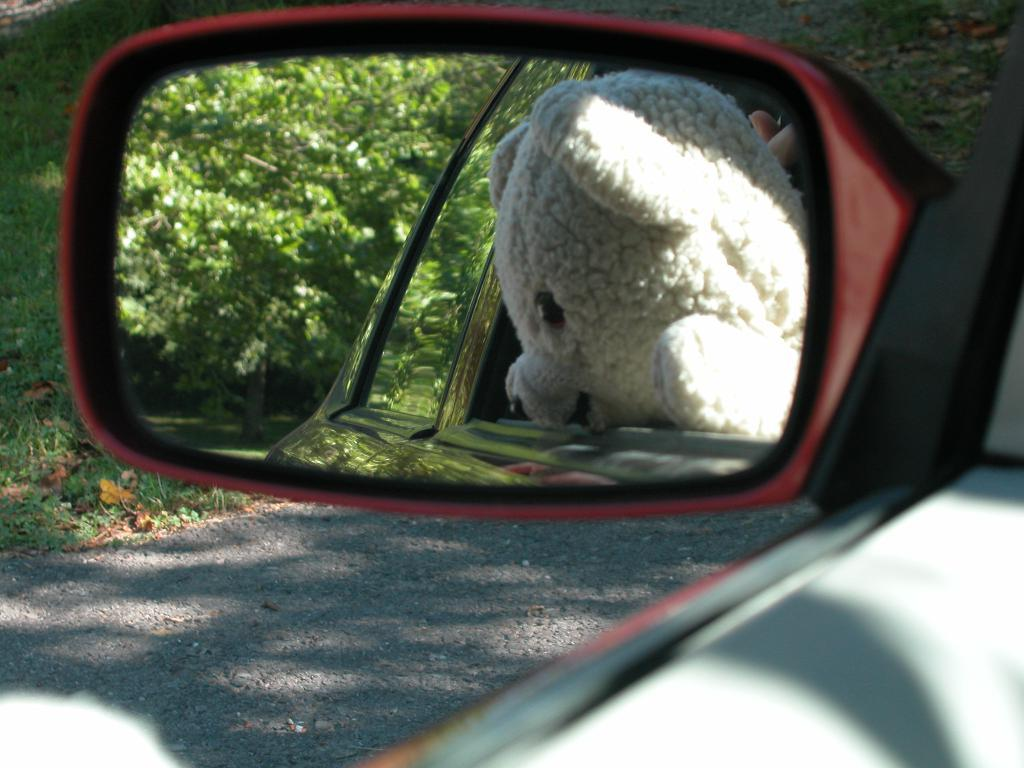What object is visible in the image that is typically found on a vehicle? There is a side mirror in the image. What can be seen in the side mirror's reflection? The side mirror reflects a teddy bear inside a car. What type of natural scenery is visible in the background of the image? There are trees in the background of the image. Can you see a snake slithering through the trees in the background of the image? There is no snake visible in the image; only trees are present in the background. 